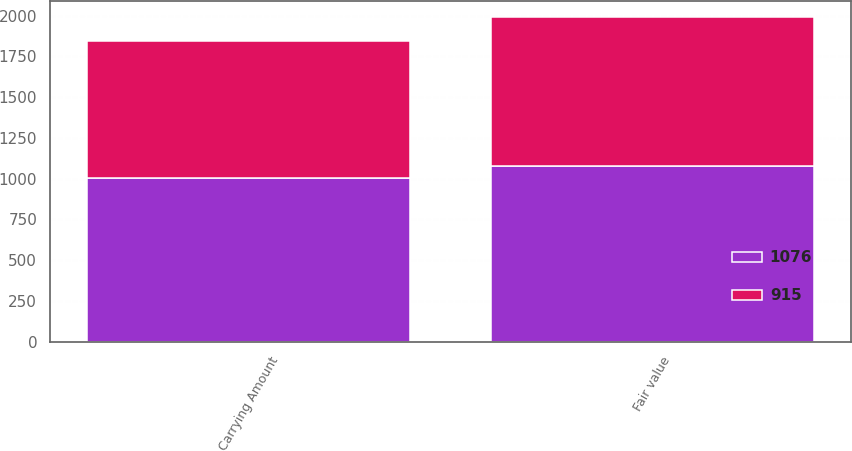Convert chart to OTSL. <chart><loc_0><loc_0><loc_500><loc_500><stacked_bar_chart><ecel><fcel>Carrying Amount<fcel>Fair value<nl><fcel>915<fcel>844<fcel>915<nl><fcel>1076<fcel>1003<fcel>1076<nl></chart> 